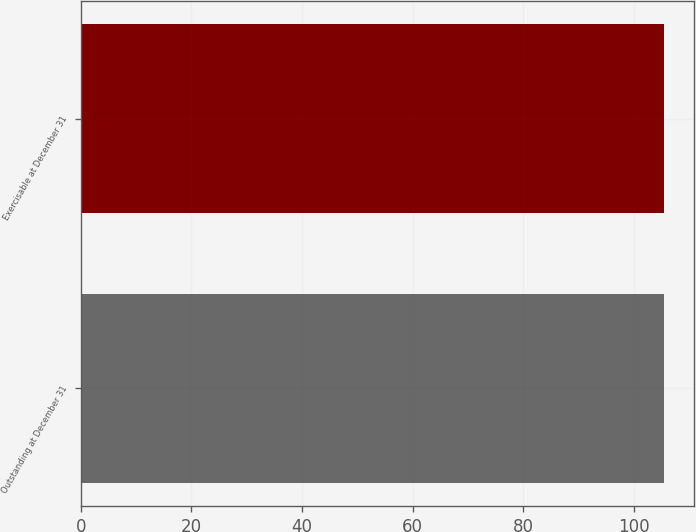<chart> <loc_0><loc_0><loc_500><loc_500><bar_chart><fcel>Outstanding at December 31<fcel>Exercisable at December 31<nl><fcel>105.48<fcel>105.49<nl></chart> 